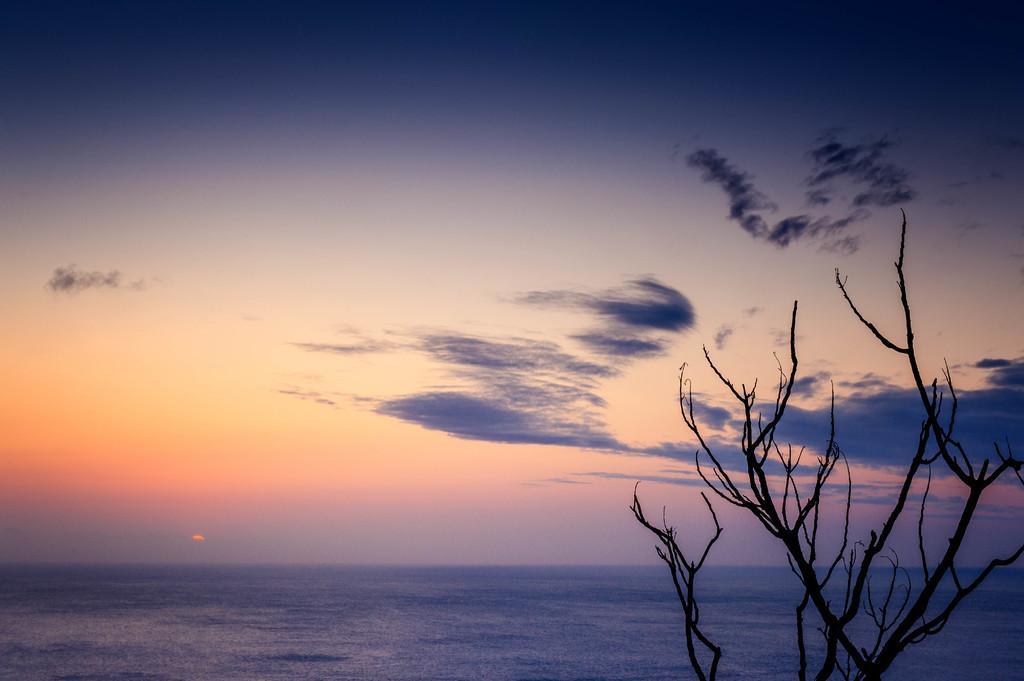Describe this image in one or two sentences. On the right side of the image, we can see the tree. At the bottom, we can see water. Background there is the sky and clouds. 